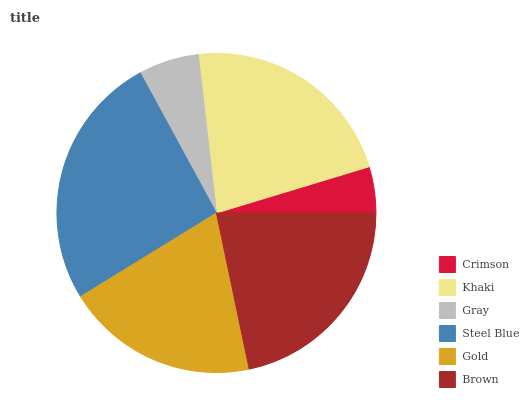Is Crimson the minimum?
Answer yes or no. Yes. Is Steel Blue the maximum?
Answer yes or no. Yes. Is Khaki the minimum?
Answer yes or no. No. Is Khaki the maximum?
Answer yes or no. No. Is Khaki greater than Crimson?
Answer yes or no. Yes. Is Crimson less than Khaki?
Answer yes or no. Yes. Is Crimson greater than Khaki?
Answer yes or no. No. Is Khaki less than Crimson?
Answer yes or no. No. Is Brown the high median?
Answer yes or no. Yes. Is Gold the low median?
Answer yes or no. Yes. Is Gold the high median?
Answer yes or no. No. Is Crimson the low median?
Answer yes or no. No. 